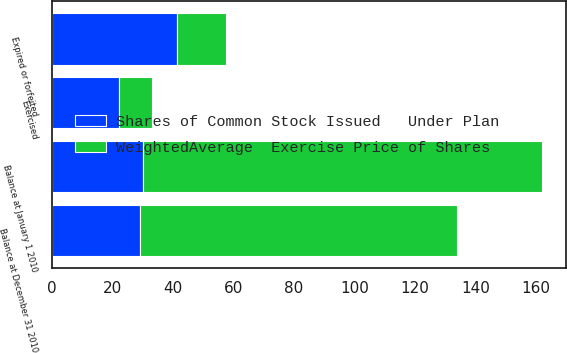Convert chart to OTSL. <chart><loc_0><loc_0><loc_500><loc_500><stacked_bar_chart><ecel><fcel>Balance at January 1 2010<fcel>Exercised<fcel>Expired or forfeited<fcel>Balance at December 31 2010<nl><fcel>WeightedAverage  Exercise Price of Shares<fcel>132<fcel>11<fcel>16<fcel>105<nl><fcel>Shares of Common Stock Issued   Under Plan<fcel>29.91<fcel>22.02<fcel>41.39<fcel>29.02<nl></chart> 